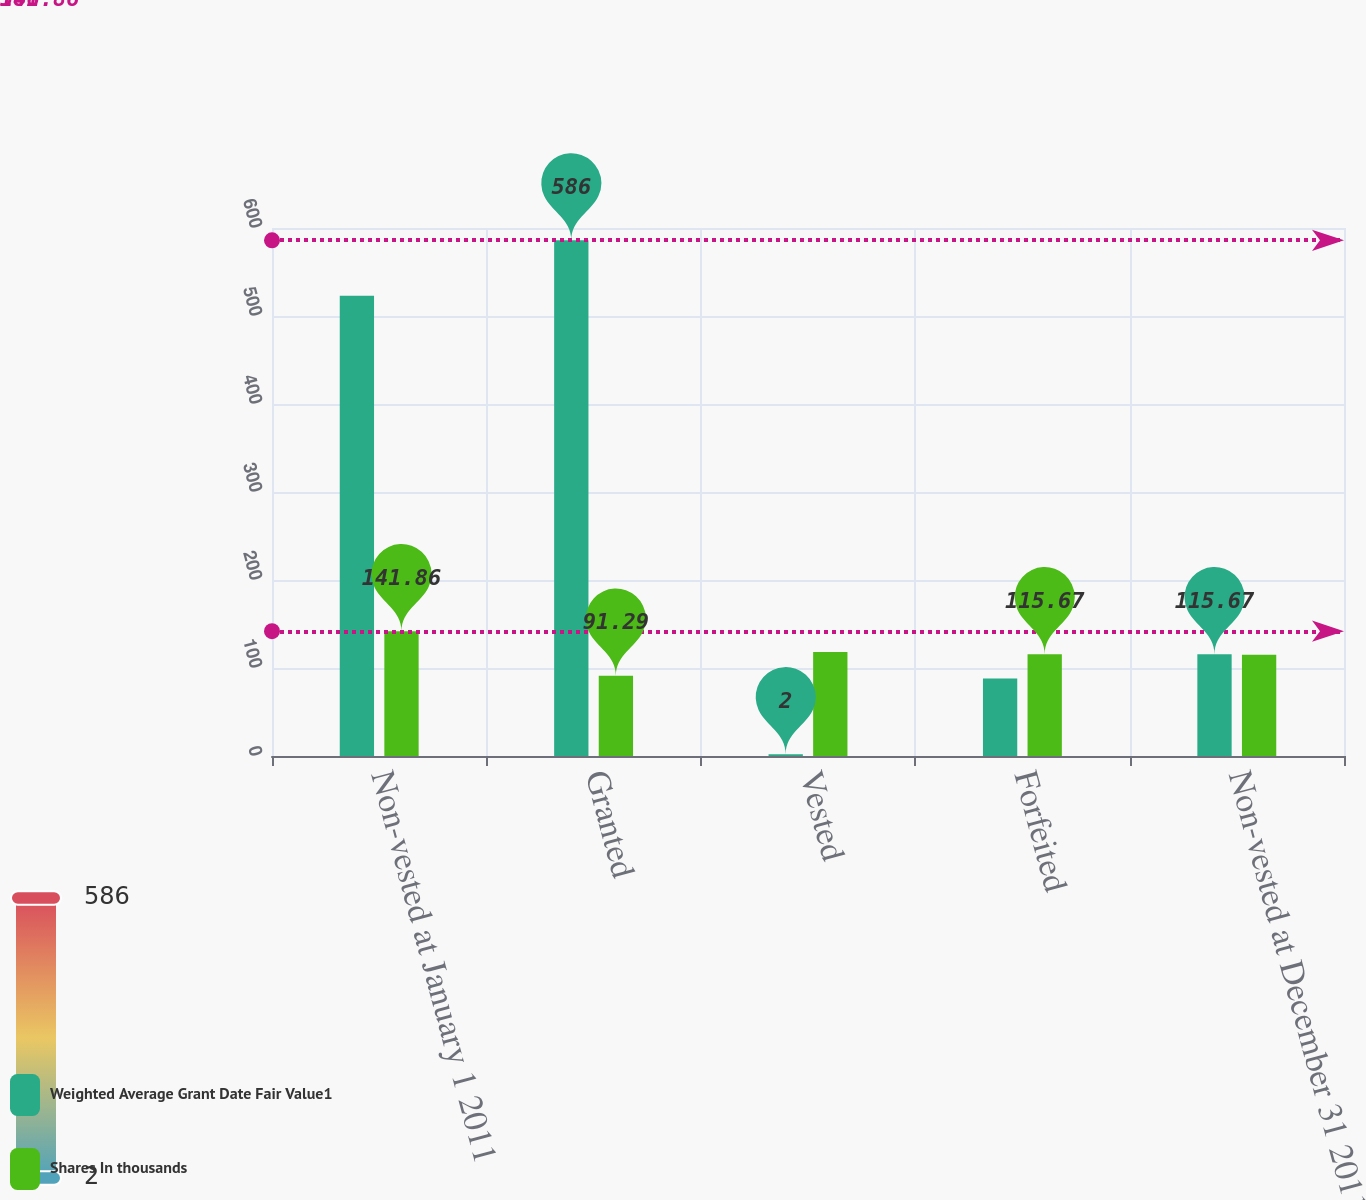Convert chart. <chart><loc_0><loc_0><loc_500><loc_500><stacked_bar_chart><ecel><fcel>Non-vested at January 1 2011<fcel>Granted<fcel>Vested<fcel>Forfeited<fcel>Non-vested at December 31 2011<nl><fcel>Weighted Average Grant Date Fair Value1<fcel>523<fcel>586<fcel>2<fcel>88<fcel>115.67<nl><fcel>Shares In thousands<fcel>141.86<fcel>91.29<fcel>118.31<fcel>115.67<fcel>115.1<nl></chart> 